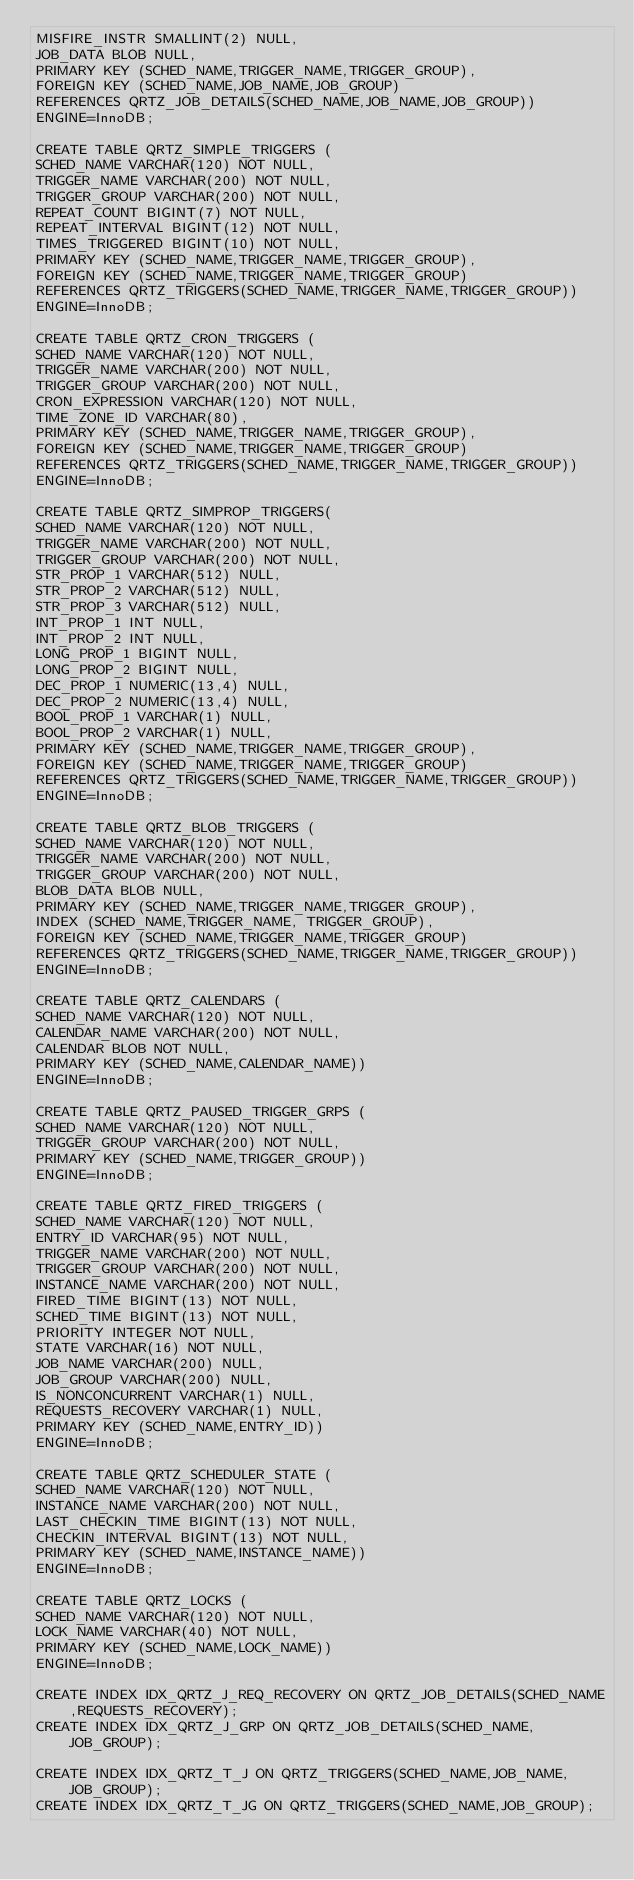Convert code to text. <code><loc_0><loc_0><loc_500><loc_500><_SQL_>MISFIRE_INSTR SMALLINT(2) NULL,
JOB_DATA BLOB NULL,
PRIMARY KEY (SCHED_NAME,TRIGGER_NAME,TRIGGER_GROUP),
FOREIGN KEY (SCHED_NAME,JOB_NAME,JOB_GROUP)
REFERENCES QRTZ_JOB_DETAILS(SCHED_NAME,JOB_NAME,JOB_GROUP))
ENGINE=InnoDB;

CREATE TABLE QRTZ_SIMPLE_TRIGGERS (
SCHED_NAME VARCHAR(120) NOT NULL,
TRIGGER_NAME VARCHAR(200) NOT NULL,
TRIGGER_GROUP VARCHAR(200) NOT NULL,
REPEAT_COUNT BIGINT(7) NOT NULL,
REPEAT_INTERVAL BIGINT(12) NOT NULL,
TIMES_TRIGGERED BIGINT(10) NOT NULL,
PRIMARY KEY (SCHED_NAME,TRIGGER_NAME,TRIGGER_GROUP),
FOREIGN KEY (SCHED_NAME,TRIGGER_NAME,TRIGGER_GROUP)
REFERENCES QRTZ_TRIGGERS(SCHED_NAME,TRIGGER_NAME,TRIGGER_GROUP))
ENGINE=InnoDB;

CREATE TABLE QRTZ_CRON_TRIGGERS (
SCHED_NAME VARCHAR(120) NOT NULL,
TRIGGER_NAME VARCHAR(200) NOT NULL,
TRIGGER_GROUP VARCHAR(200) NOT NULL,
CRON_EXPRESSION VARCHAR(120) NOT NULL,
TIME_ZONE_ID VARCHAR(80),
PRIMARY KEY (SCHED_NAME,TRIGGER_NAME,TRIGGER_GROUP),
FOREIGN KEY (SCHED_NAME,TRIGGER_NAME,TRIGGER_GROUP)
REFERENCES QRTZ_TRIGGERS(SCHED_NAME,TRIGGER_NAME,TRIGGER_GROUP))
ENGINE=InnoDB;

CREATE TABLE QRTZ_SIMPROP_TRIGGERS(          
SCHED_NAME VARCHAR(120) NOT NULL,
TRIGGER_NAME VARCHAR(200) NOT NULL,
TRIGGER_GROUP VARCHAR(200) NOT NULL,
STR_PROP_1 VARCHAR(512) NULL,
STR_PROP_2 VARCHAR(512) NULL,
STR_PROP_3 VARCHAR(512) NULL,
INT_PROP_1 INT NULL,
INT_PROP_2 INT NULL,
LONG_PROP_1 BIGINT NULL,
LONG_PROP_2 BIGINT NULL,
DEC_PROP_1 NUMERIC(13,4) NULL,
DEC_PROP_2 NUMERIC(13,4) NULL,
BOOL_PROP_1 VARCHAR(1) NULL,
BOOL_PROP_2 VARCHAR(1) NULL,
PRIMARY KEY (SCHED_NAME,TRIGGER_NAME,TRIGGER_GROUP),
FOREIGN KEY (SCHED_NAME,TRIGGER_NAME,TRIGGER_GROUP) 
REFERENCES QRTZ_TRIGGERS(SCHED_NAME,TRIGGER_NAME,TRIGGER_GROUP))
ENGINE=InnoDB;

CREATE TABLE QRTZ_BLOB_TRIGGERS (
SCHED_NAME VARCHAR(120) NOT NULL,
TRIGGER_NAME VARCHAR(200) NOT NULL,
TRIGGER_GROUP VARCHAR(200) NOT NULL,
BLOB_DATA BLOB NULL,
PRIMARY KEY (SCHED_NAME,TRIGGER_NAME,TRIGGER_GROUP),
INDEX (SCHED_NAME,TRIGGER_NAME, TRIGGER_GROUP),
FOREIGN KEY (SCHED_NAME,TRIGGER_NAME,TRIGGER_GROUP)
REFERENCES QRTZ_TRIGGERS(SCHED_NAME,TRIGGER_NAME,TRIGGER_GROUP))
ENGINE=InnoDB;

CREATE TABLE QRTZ_CALENDARS (
SCHED_NAME VARCHAR(120) NOT NULL,
CALENDAR_NAME VARCHAR(200) NOT NULL,
CALENDAR BLOB NOT NULL,
PRIMARY KEY (SCHED_NAME,CALENDAR_NAME))
ENGINE=InnoDB;

CREATE TABLE QRTZ_PAUSED_TRIGGER_GRPS (
SCHED_NAME VARCHAR(120) NOT NULL,
TRIGGER_GROUP VARCHAR(200) NOT NULL,
PRIMARY KEY (SCHED_NAME,TRIGGER_GROUP))
ENGINE=InnoDB;

CREATE TABLE QRTZ_FIRED_TRIGGERS (
SCHED_NAME VARCHAR(120) NOT NULL,
ENTRY_ID VARCHAR(95) NOT NULL,
TRIGGER_NAME VARCHAR(200) NOT NULL,
TRIGGER_GROUP VARCHAR(200) NOT NULL,
INSTANCE_NAME VARCHAR(200) NOT NULL,
FIRED_TIME BIGINT(13) NOT NULL,
SCHED_TIME BIGINT(13) NOT NULL,
PRIORITY INTEGER NOT NULL,
STATE VARCHAR(16) NOT NULL,
JOB_NAME VARCHAR(200) NULL,
JOB_GROUP VARCHAR(200) NULL,
IS_NONCONCURRENT VARCHAR(1) NULL,
REQUESTS_RECOVERY VARCHAR(1) NULL,
PRIMARY KEY (SCHED_NAME,ENTRY_ID))
ENGINE=InnoDB;

CREATE TABLE QRTZ_SCHEDULER_STATE (
SCHED_NAME VARCHAR(120) NOT NULL,
INSTANCE_NAME VARCHAR(200) NOT NULL,
LAST_CHECKIN_TIME BIGINT(13) NOT NULL,
CHECKIN_INTERVAL BIGINT(13) NOT NULL,
PRIMARY KEY (SCHED_NAME,INSTANCE_NAME))
ENGINE=InnoDB;

CREATE TABLE QRTZ_LOCKS (
SCHED_NAME VARCHAR(120) NOT NULL,
LOCK_NAME VARCHAR(40) NOT NULL,
PRIMARY KEY (SCHED_NAME,LOCK_NAME))
ENGINE=InnoDB;

CREATE INDEX IDX_QRTZ_J_REQ_RECOVERY ON QRTZ_JOB_DETAILS(SCHED_NAME,REQUESTS_RECOVERY);
CREATE INDEX IDX_QRTZ_J_GRP ON QRTZ_JOB_DETAILS(SCHED_NAME,JOB_GROUP);

CREATE INDEX IDX_QRTZ_T_J ON QRTZ_TRIGGERS(SCHED_NAME,JOB_NAME,JOB_GROUP);
CREATE INDEX IDX_QRTZ_T_JG ON QRTZ_TRIGGERS(SCHED_NAME,JOB_GROUP);</code> 